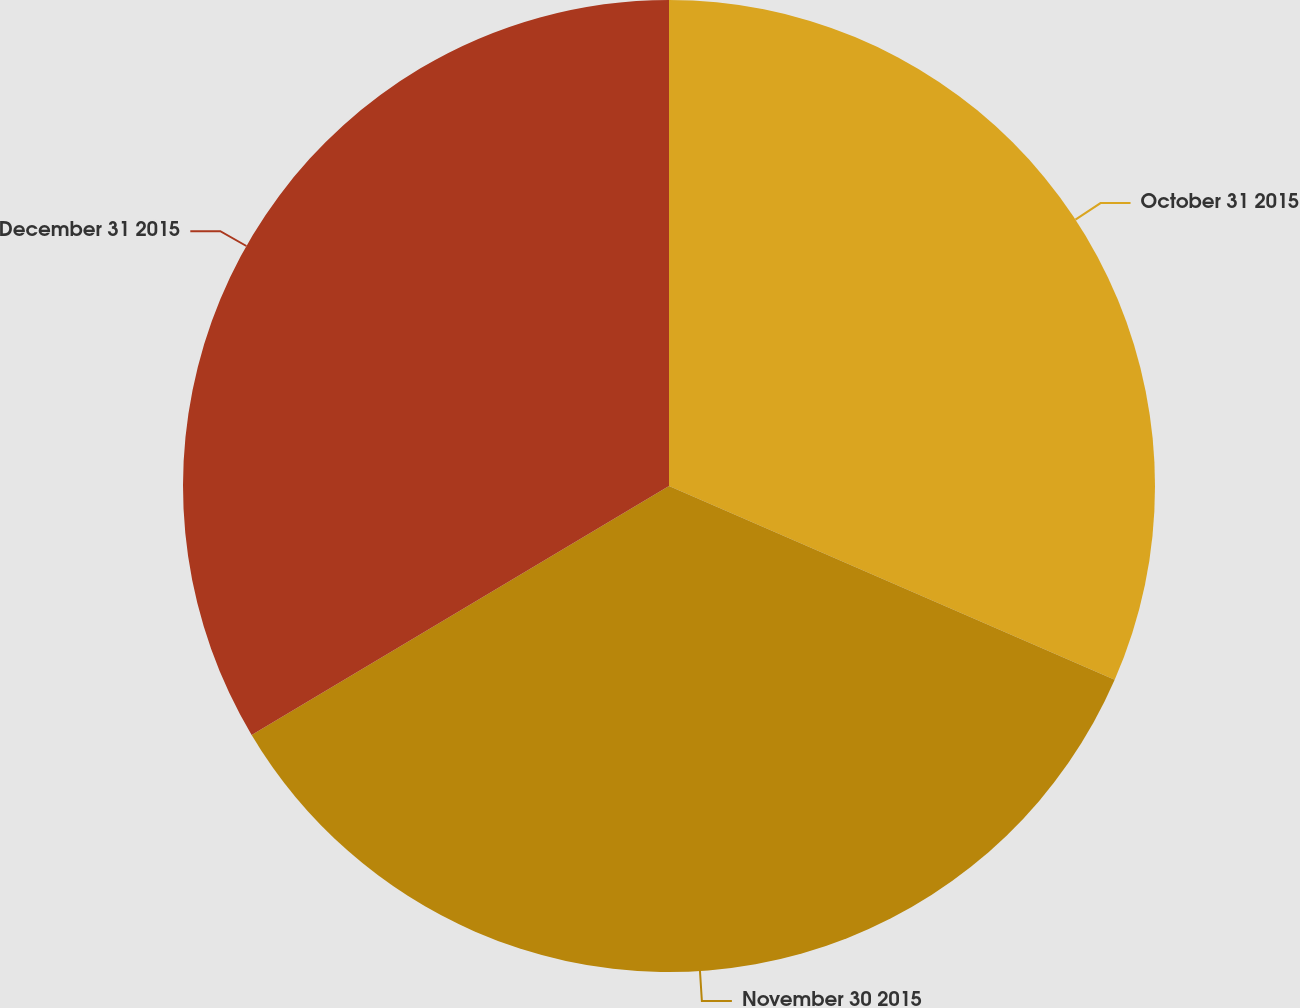<chart> <loc_0><loc_0><loc_500><loc_500><pie_chart><fcel>October 31 2015<fcel>November 30 2015<fcel>December 31 2015<nl><fcel>31.53%<fcel>34.91%<fcel>33.56%<nl></chart> 